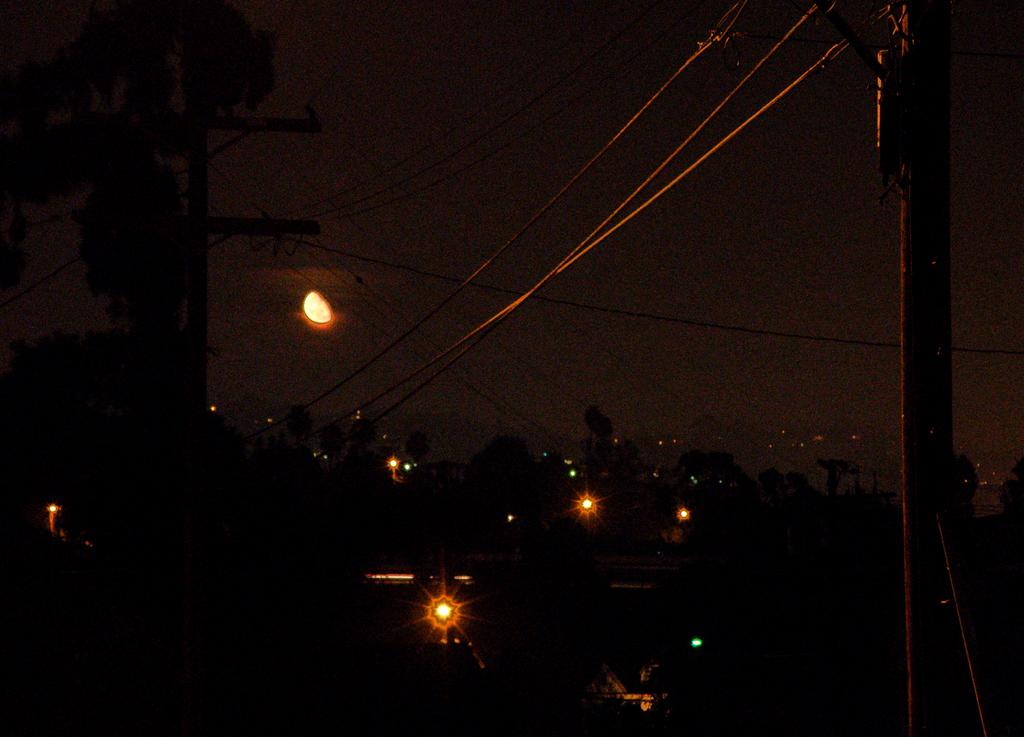What type of structures can be seen in the image? There are buildings in the image. What other natural elements are present in the image? There are trees in the image. What are the poles used for in the image? The poles are used to hold wires in the image. What is visible at the top of the image? The sky is visible at the top of the image, and there is a moon in the sky. Can you see a hand holding the moon in the image? No, there is no hand holding the moon in the image. Is there a doll sitting on top of one of the buildings in the image? No, there is no doll present in the image. 